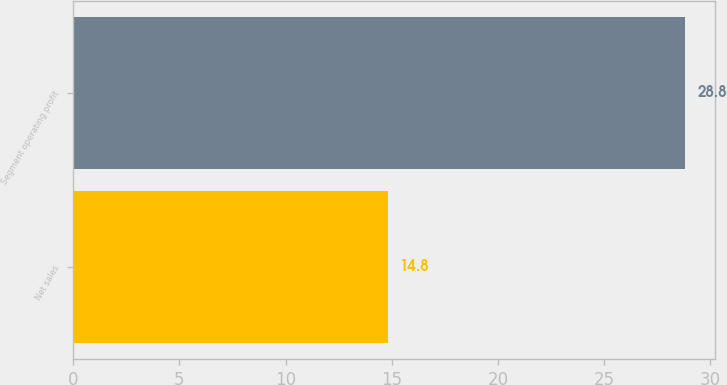Convert chart. <chart><loc_0><loc_0><loc_500><loc_500><bar_chart><fcel>Net sales<fcel>Segment operating profit<nl><fcel>14.8<fcel>28.8<nl></chart> 